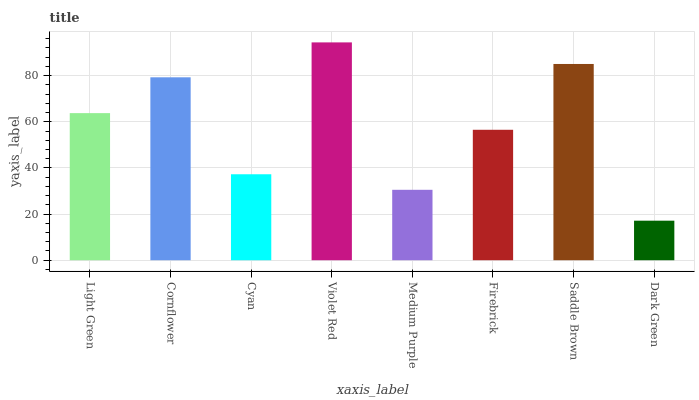Is Cornflower the minimum?
Answer yes or no. No. Is Cornflower the maximum?
Answer yes or no. No. Is Cornflower greater than Light Green?
Answer yes or no. Yes. Is Light Green less than Cornflower?
Answer yes or no. Yes. Is Light Green greater than Cornflower?
Answer yes or no. No. Is Cornflower less than Light Green?
Answer yes or no. No. Is Light Green the high median?
Answer yes or no. Yes. Is Firebrick the low median?
Answer yes or no. Yes. Is Cyan the high median?
Answer yes or no. No. Is Dark Green the low median?
Answer yes or no. No. 